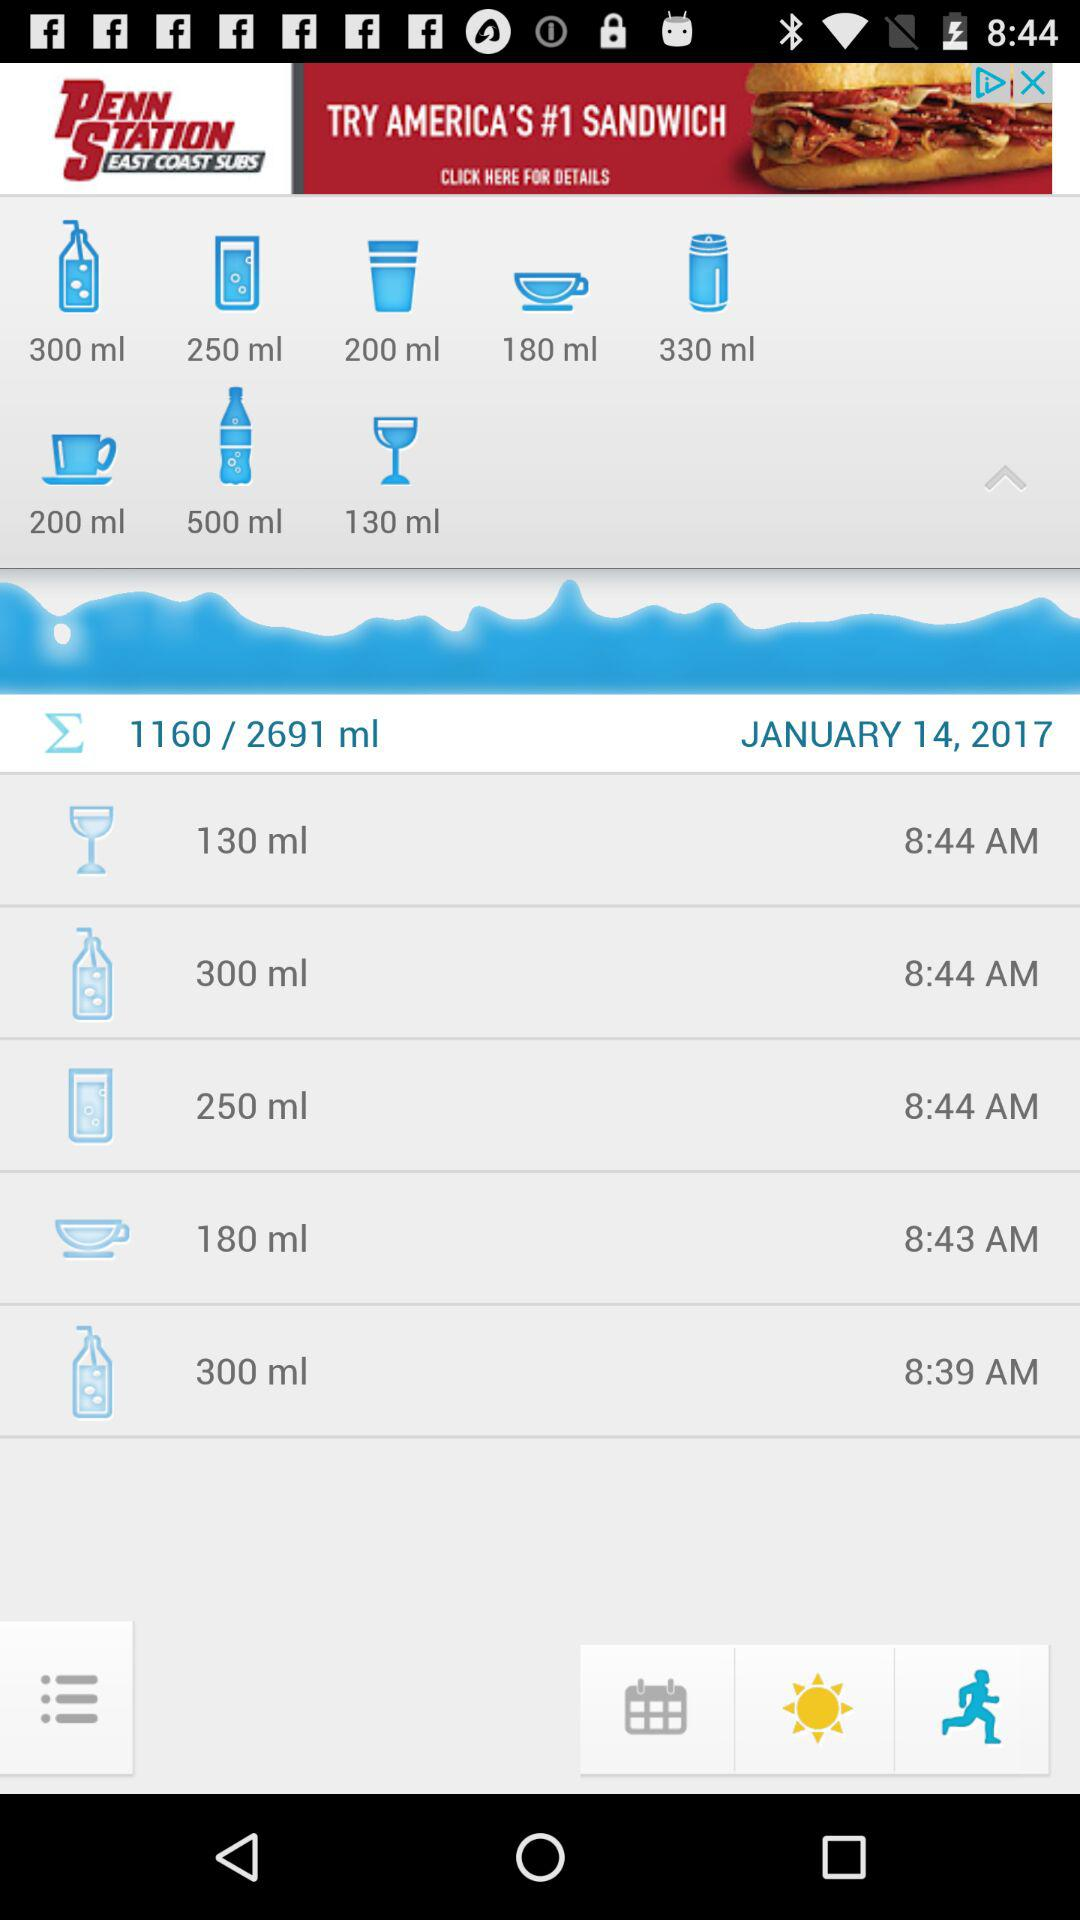What is the time mentioned for 130 ml? The time mentioned for 130 ml is 8:44 AM. 